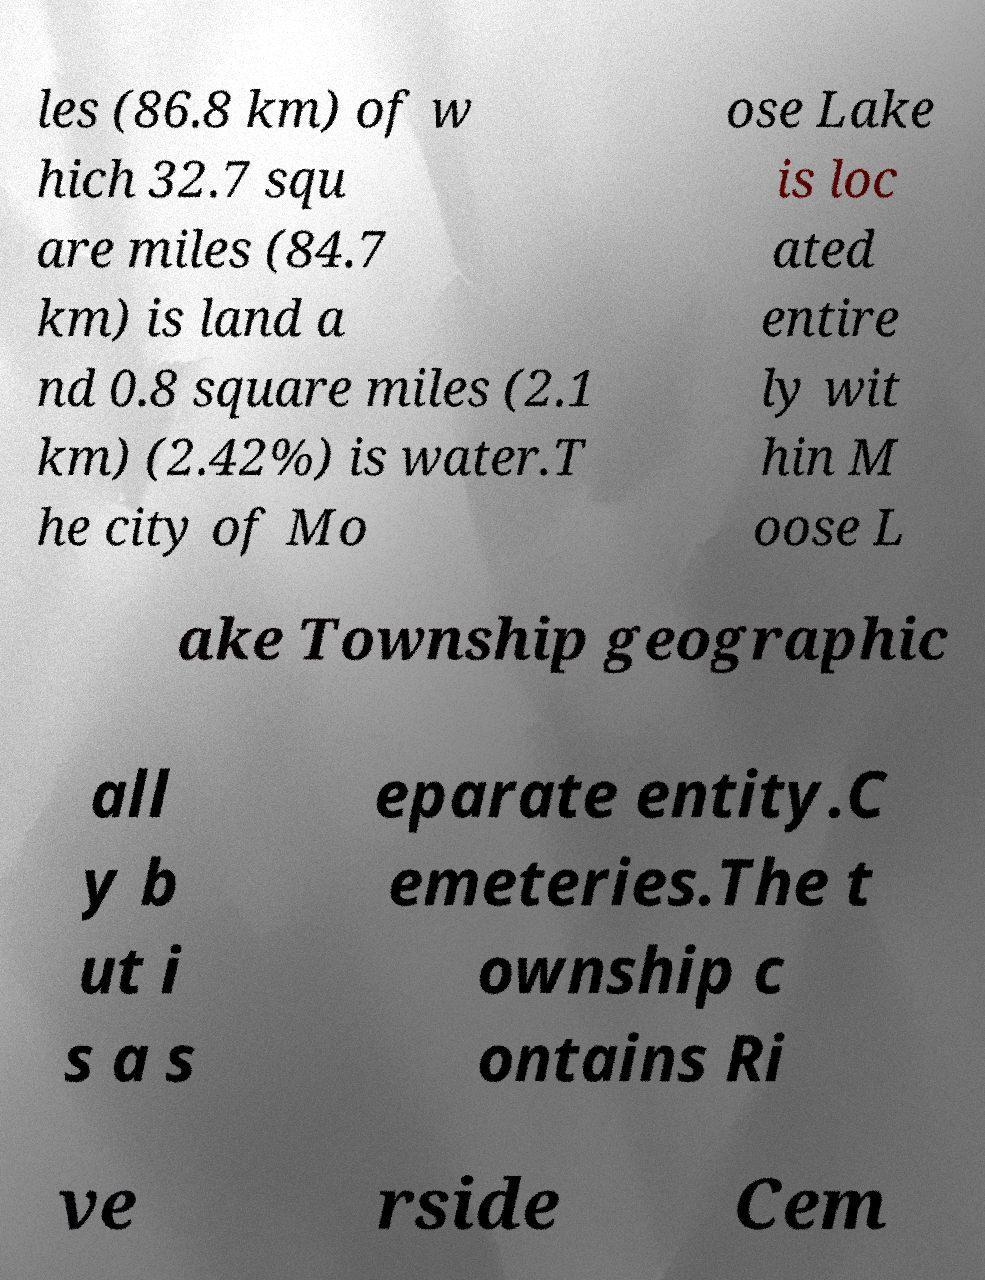Please identify and transcribe the text found in this image. les (86.8 km) of w hich 32.7 squ are miles (84.7 km) is land a nd 0.8 square miles (2.1 km) (2.42%) is water.T he city of Mo ose Lake is loc ated entire ly wit hin M oose L ake Township geographic all y b ut i s a s eparate entity.C emeteries.The t ownship c ontains Ri ve rside Cem 